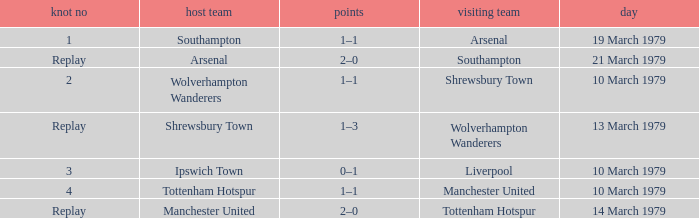What was the score of the tie that had Tottenham Hotspur as the home team? 1–1. 